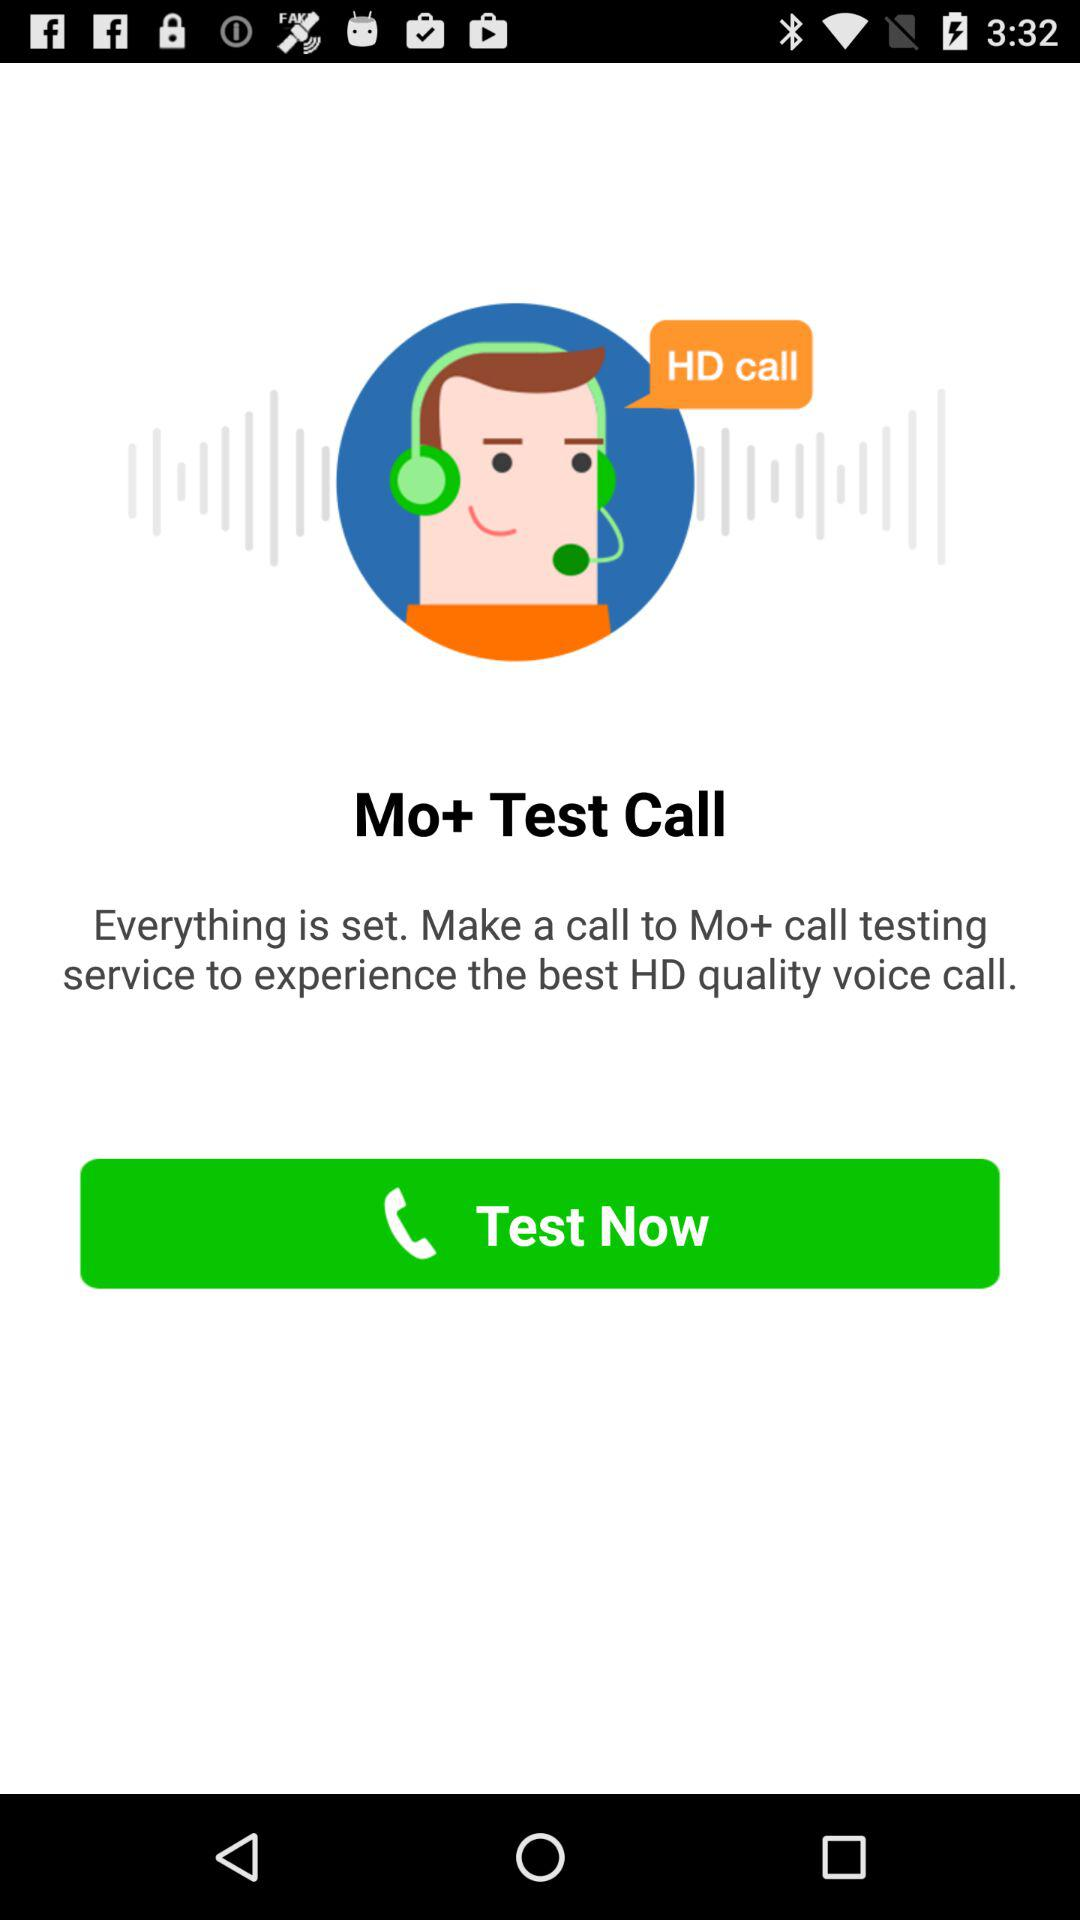Did calling the testing service work?
When the provided information is insufficient, respond with <no answer>. <no answer> 